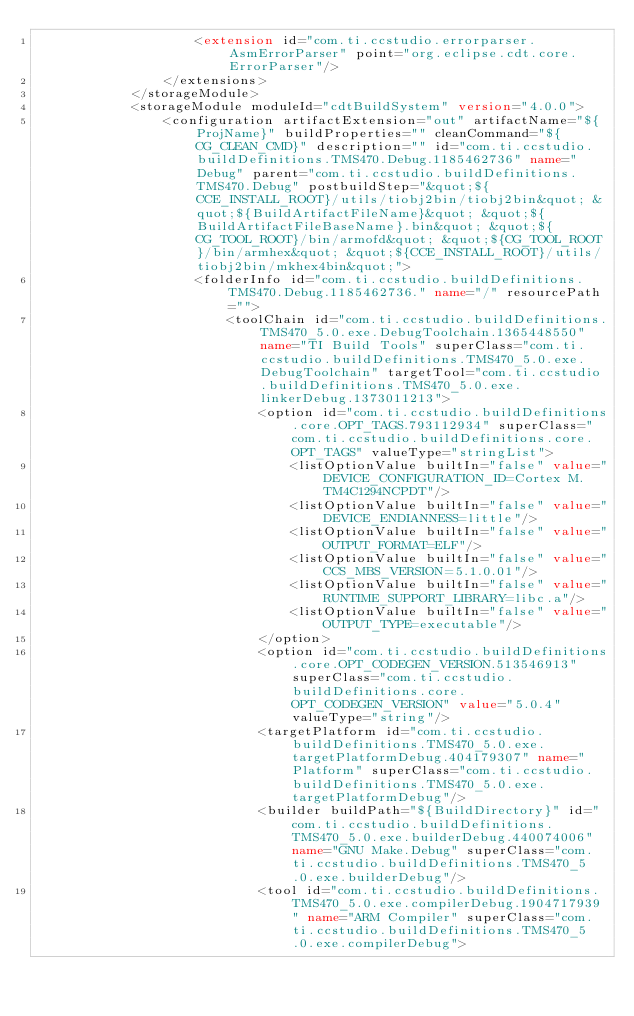Convert code to text. <code><loc_0><loc_0><loc_500><loc_500><_XML_>					<extension id="com.ti.ccstudio.errorparser.AsmErrorParser" point="org.eclipse.cdt.core.ErrorParser"/>
				</extensions>
			</storageModule>
			<storageModule moduleId="cdtBuildSystem" version="4.0.0">
				<configuration artifactExtension="out" artifactName="${ProjName}" buildProperties="" cleanCommand="${CG_CLEAN_CMD}" description="" id="com.ti.ccstudio.buildDefinitions.TMS470.Debug.1185462736" name="Debug" parent="com.ti.ccstudio.buildDefinitions.TMS470.Debug" postbuildStep="&quot;${CCE_INSTALL_ROOT}/utils/tiobj2bin/tiobj2bin&quot; &quot;${BuildArtifactFileName}&quot; &quot;${BuildArtifactFileBaseName}.bin&quot; &quot;${CG_TOOL_ROOT}/bin/armofd&quot; &quot;${CG_TOOL_ROOT}/bin/armhex&quot; &quot;${CCE_INSTALL_ROOT}/utils/tiobj2bin/mkhex4bin&quot;">
					<folderInfo id="com.ti.ccstudio.buildDefinitions.TMS470.Debug.1185462736." name="/" resourcePath="">
						<toolChain id="com.ti.ccstudio.buildDefinitions.TMS470_5.0.exe.DebugToolchain.1365448550" name="TI Build Tools" superClass="com.ti.ccstudio.buildDefinitions.TMS470_5.0.exe.DebugToolchain" targetTool="com.ti.ccstudio.buildDefinitions.TMS470_5.0.exe.linkerDebug.1373011213">
							<option id="com.ti.ccstudio.buildDefinitions.core.OPT_TAGS.793112934" superClass="com.ti.ccstudio.buildDefinitions.core.OPT_TAGS" valueType="stringList">
								<listOptionValue builtIn="false" value="DEVICE_CONFIGURATION_ID=Cortex M.TM4C1294NCPDT"/>
								<listOptionValue builtIn="false" value="DEVICE_ENDIANNESS=little"/>
								<listOptionValue builtIn="false" value="OUTPUT_FORMAT=ELF"/>
								<listOptionValue builtIn="false" value="CCS_MBS_VERSION=5.1.0.01"/>
								<listOptionValue builtIn="false" value="RUNTIME_SUPPORT_LIBRARY=libc.a"/>
								<listOptionValue builtIn="false" value="OUTPUT_TYPE=executable"/>
							</option>
							<option id="com.ti.ccstudio.buildDefinitions.core.OPT_CODEGEN_VERSION.513546913" superClass="com.ti.ccstudio.buildDefinitions.core.OPT_CODEGEN_VERSION" value="5.0.4" valueType="string"/>
							<targetPlatform id="com.ti.ccstudio.buildDefinitions.TMS470_5.0.exe.targetPlatformDebug.404179307" name="Platform" superClass="com.ti.ccstudio.buildDefinitions.TMS470_5.0.exe.targetPlatformDebug"/>
							<builder buildPath="${BuildDirectory}" id="com.ti.ccstudio.buildDefinitions.TMS470_5.0.exe.builderDebug.440074006" name="GNU Make.Debug" superClass="com.ti.ccstudio.buildDefinitions.TMS470_5.0.exe.builderDebug"/>
							<tool id="com.ti.ccstudio.buildDefinitions.TMS470_5.0.exe.compilerDebug.1904717939" name="ARM Compiler" superClass="com.ti.ccstudio.buildDefinitions.TMS470_5.0.exe.compilerDebug"></code> 